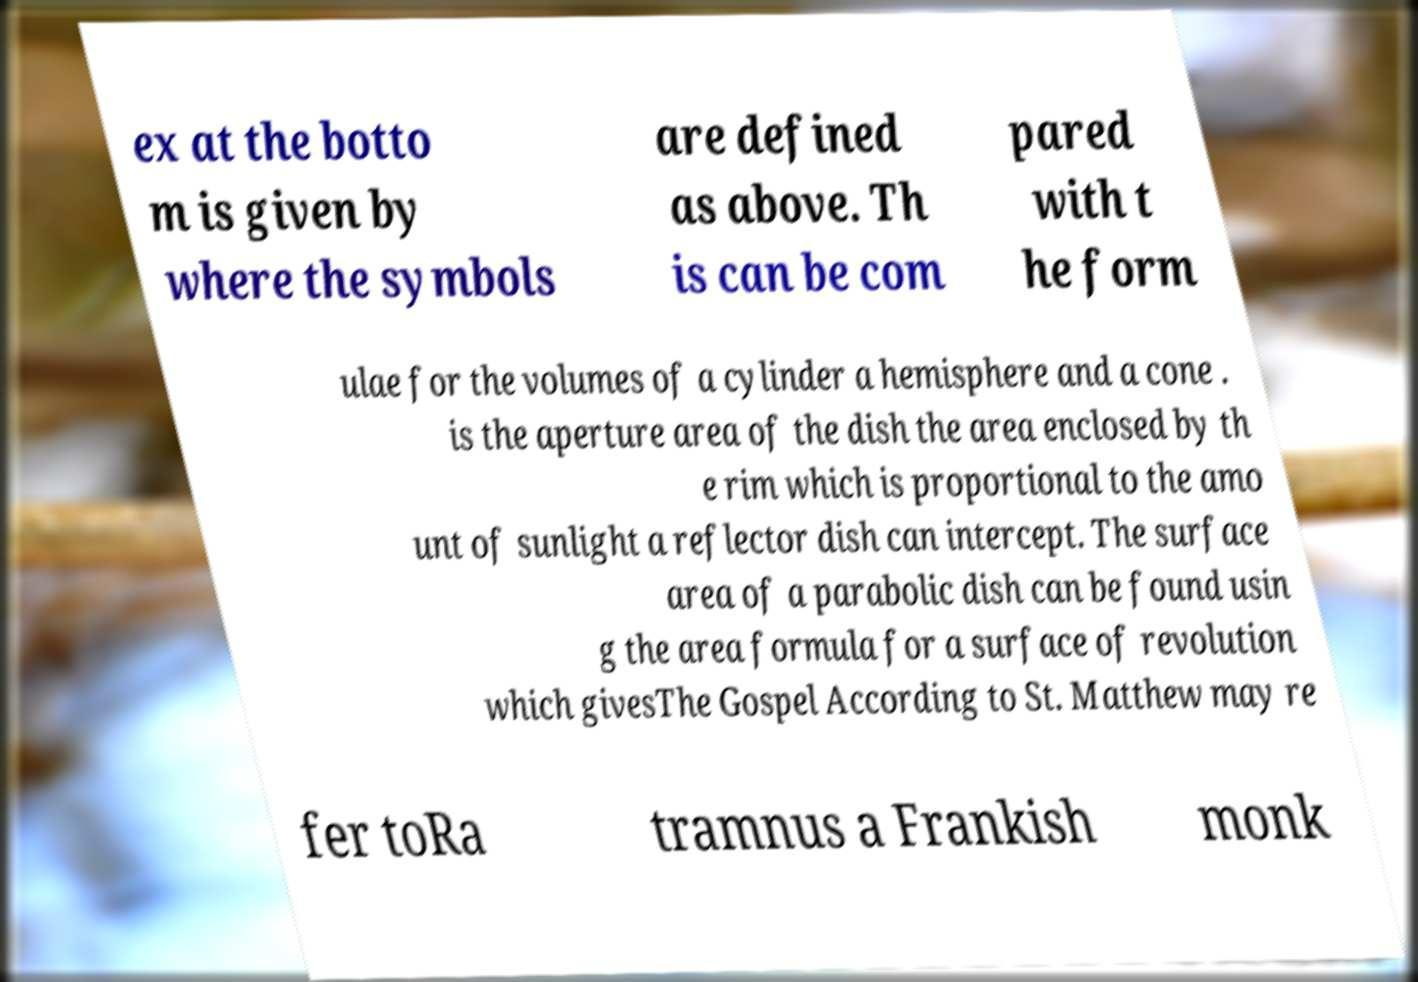Can you read and provide the text displayed in the image?This photo seems to have some interesting text. Can you extract and type it out for me? ex at the botto m is given by where the symbols are defined as above. Th is can be com pared with t he form ulae for the volumes of a cylinder a hemisphere and a cone . is the aperture area of the dish the area enclosed by th e rim which is proportional to the amo unt of sunlight a reflector dish can intercept. The surface area of a parabolic dish can be found usin g the area formula for a surface of revolution which givesThe Gospel According to St. Matthew may re fer toRa tramnus a Frankish monk 